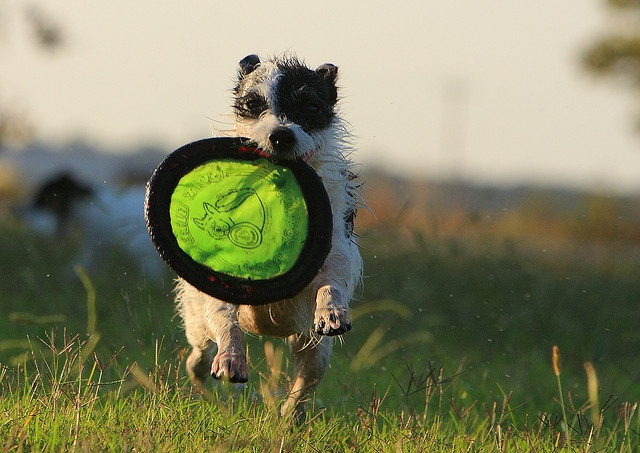Describe the objects in this image and their specific colors. I can see dog in beige, black, gray, olive, and lightgreen tones and frisbee in beige, black, lightgreen, olive, and darkgreen tones in this image. 